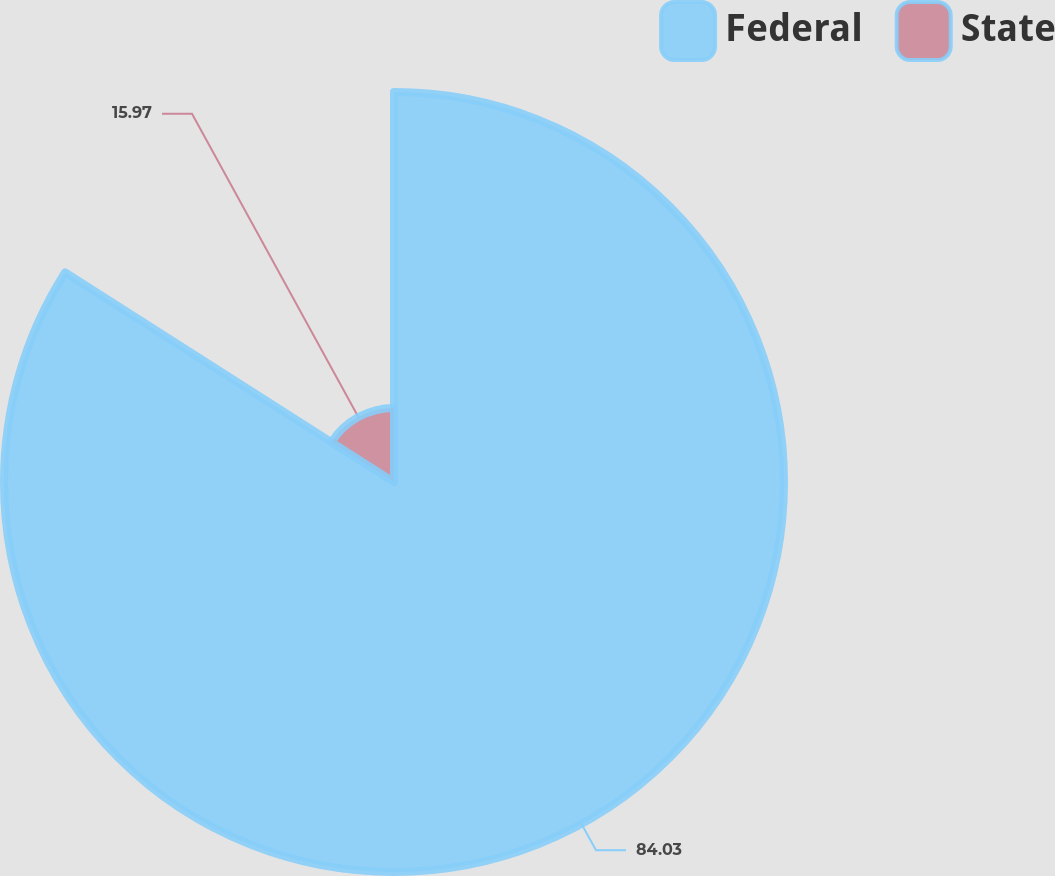Convert chart to OTSL. <chart><loc_0><loc_0><loc_500><loc_500><pie_chart><fcel>Federal<fcel>State<nl><fcel>84.03%<fcel>15.97%<nl></chart> 